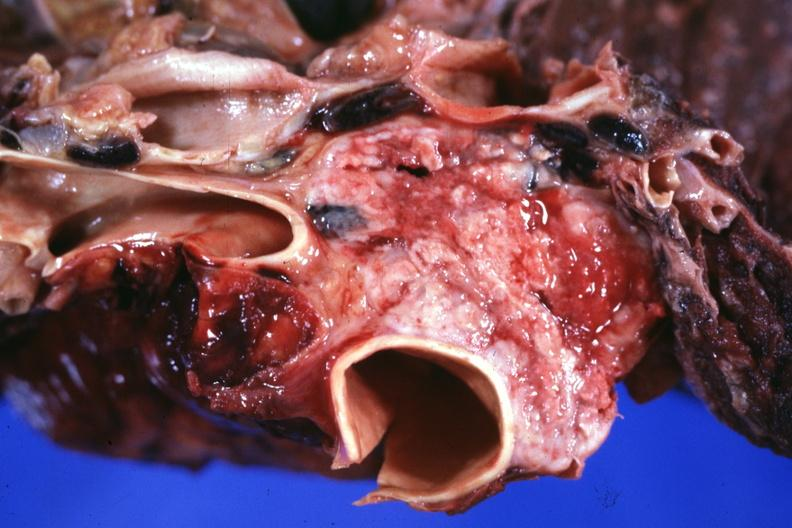how does this image show section through mediastinum to show tumor?
Answer the question using a single word or phrase. Surrounding vessels 